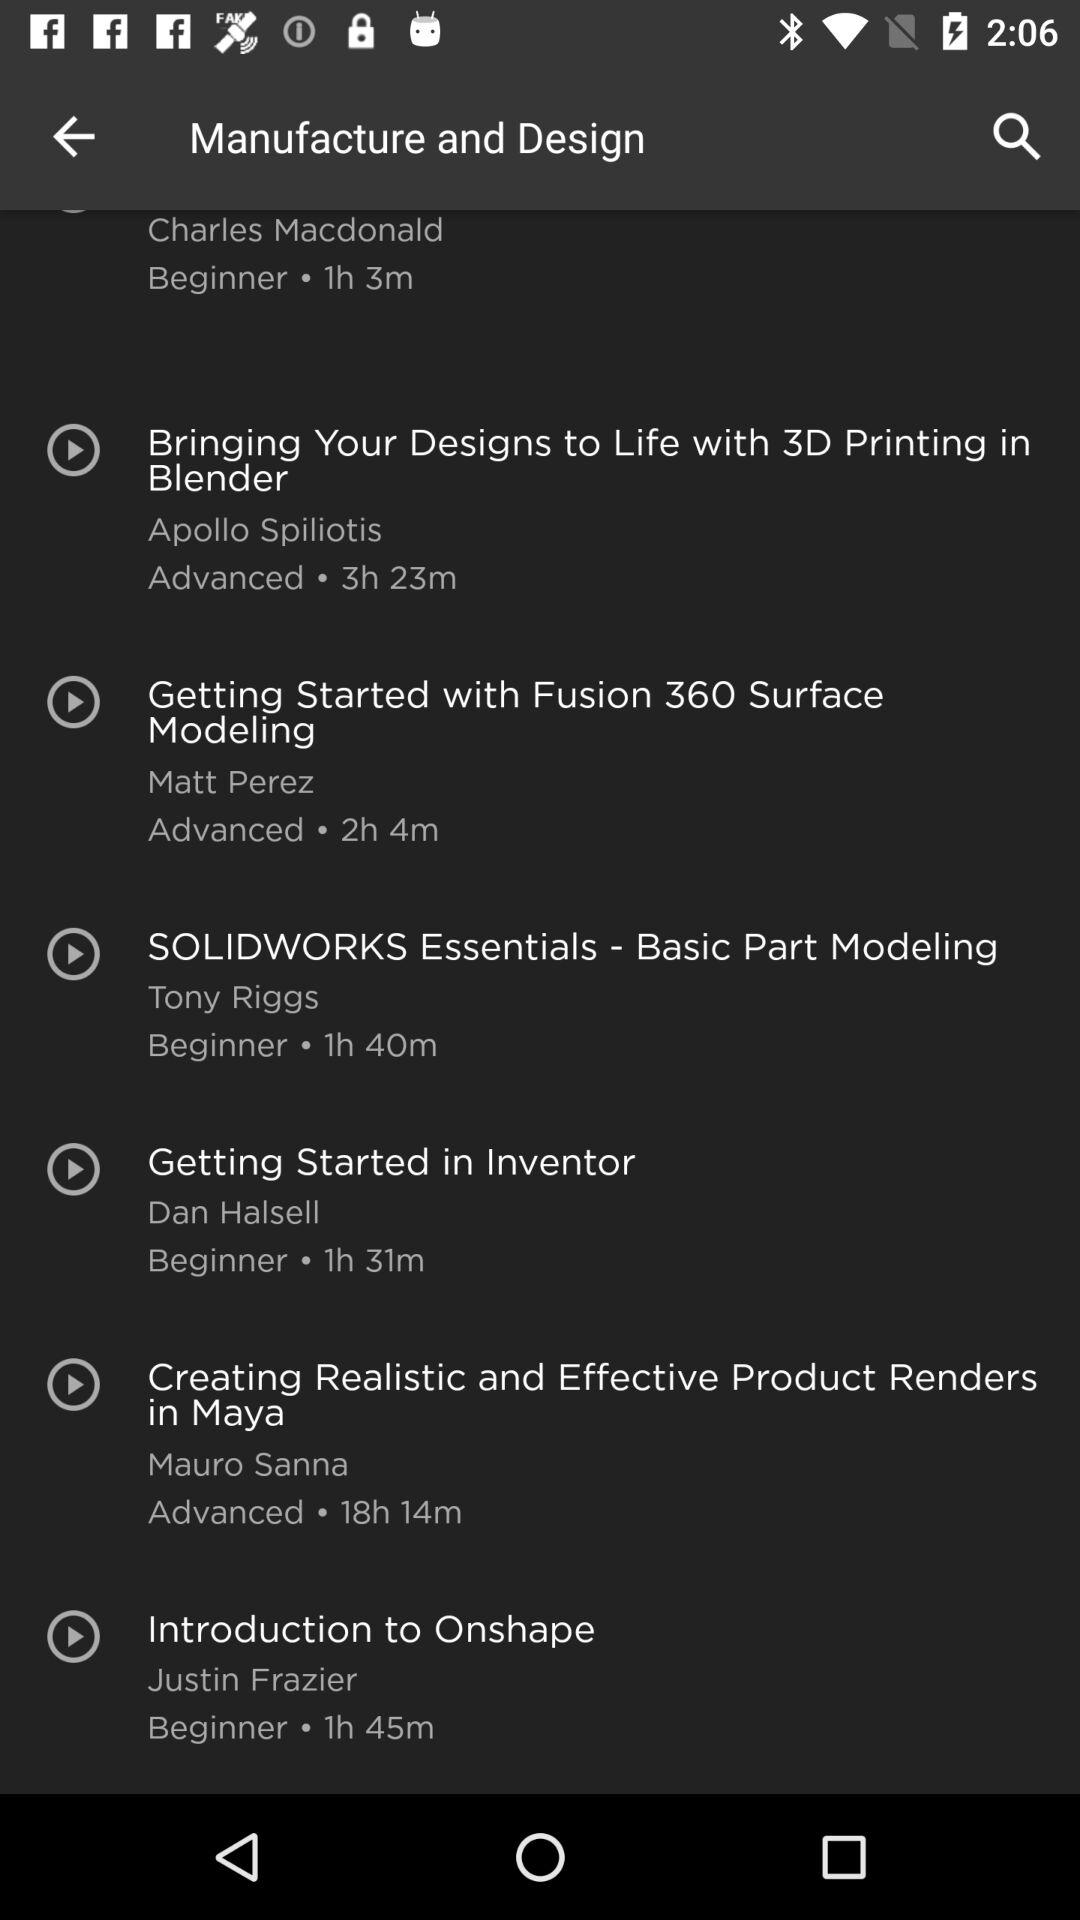How many hours is the longest course?
Answer the question using a single word or phrase. 18h 14m 